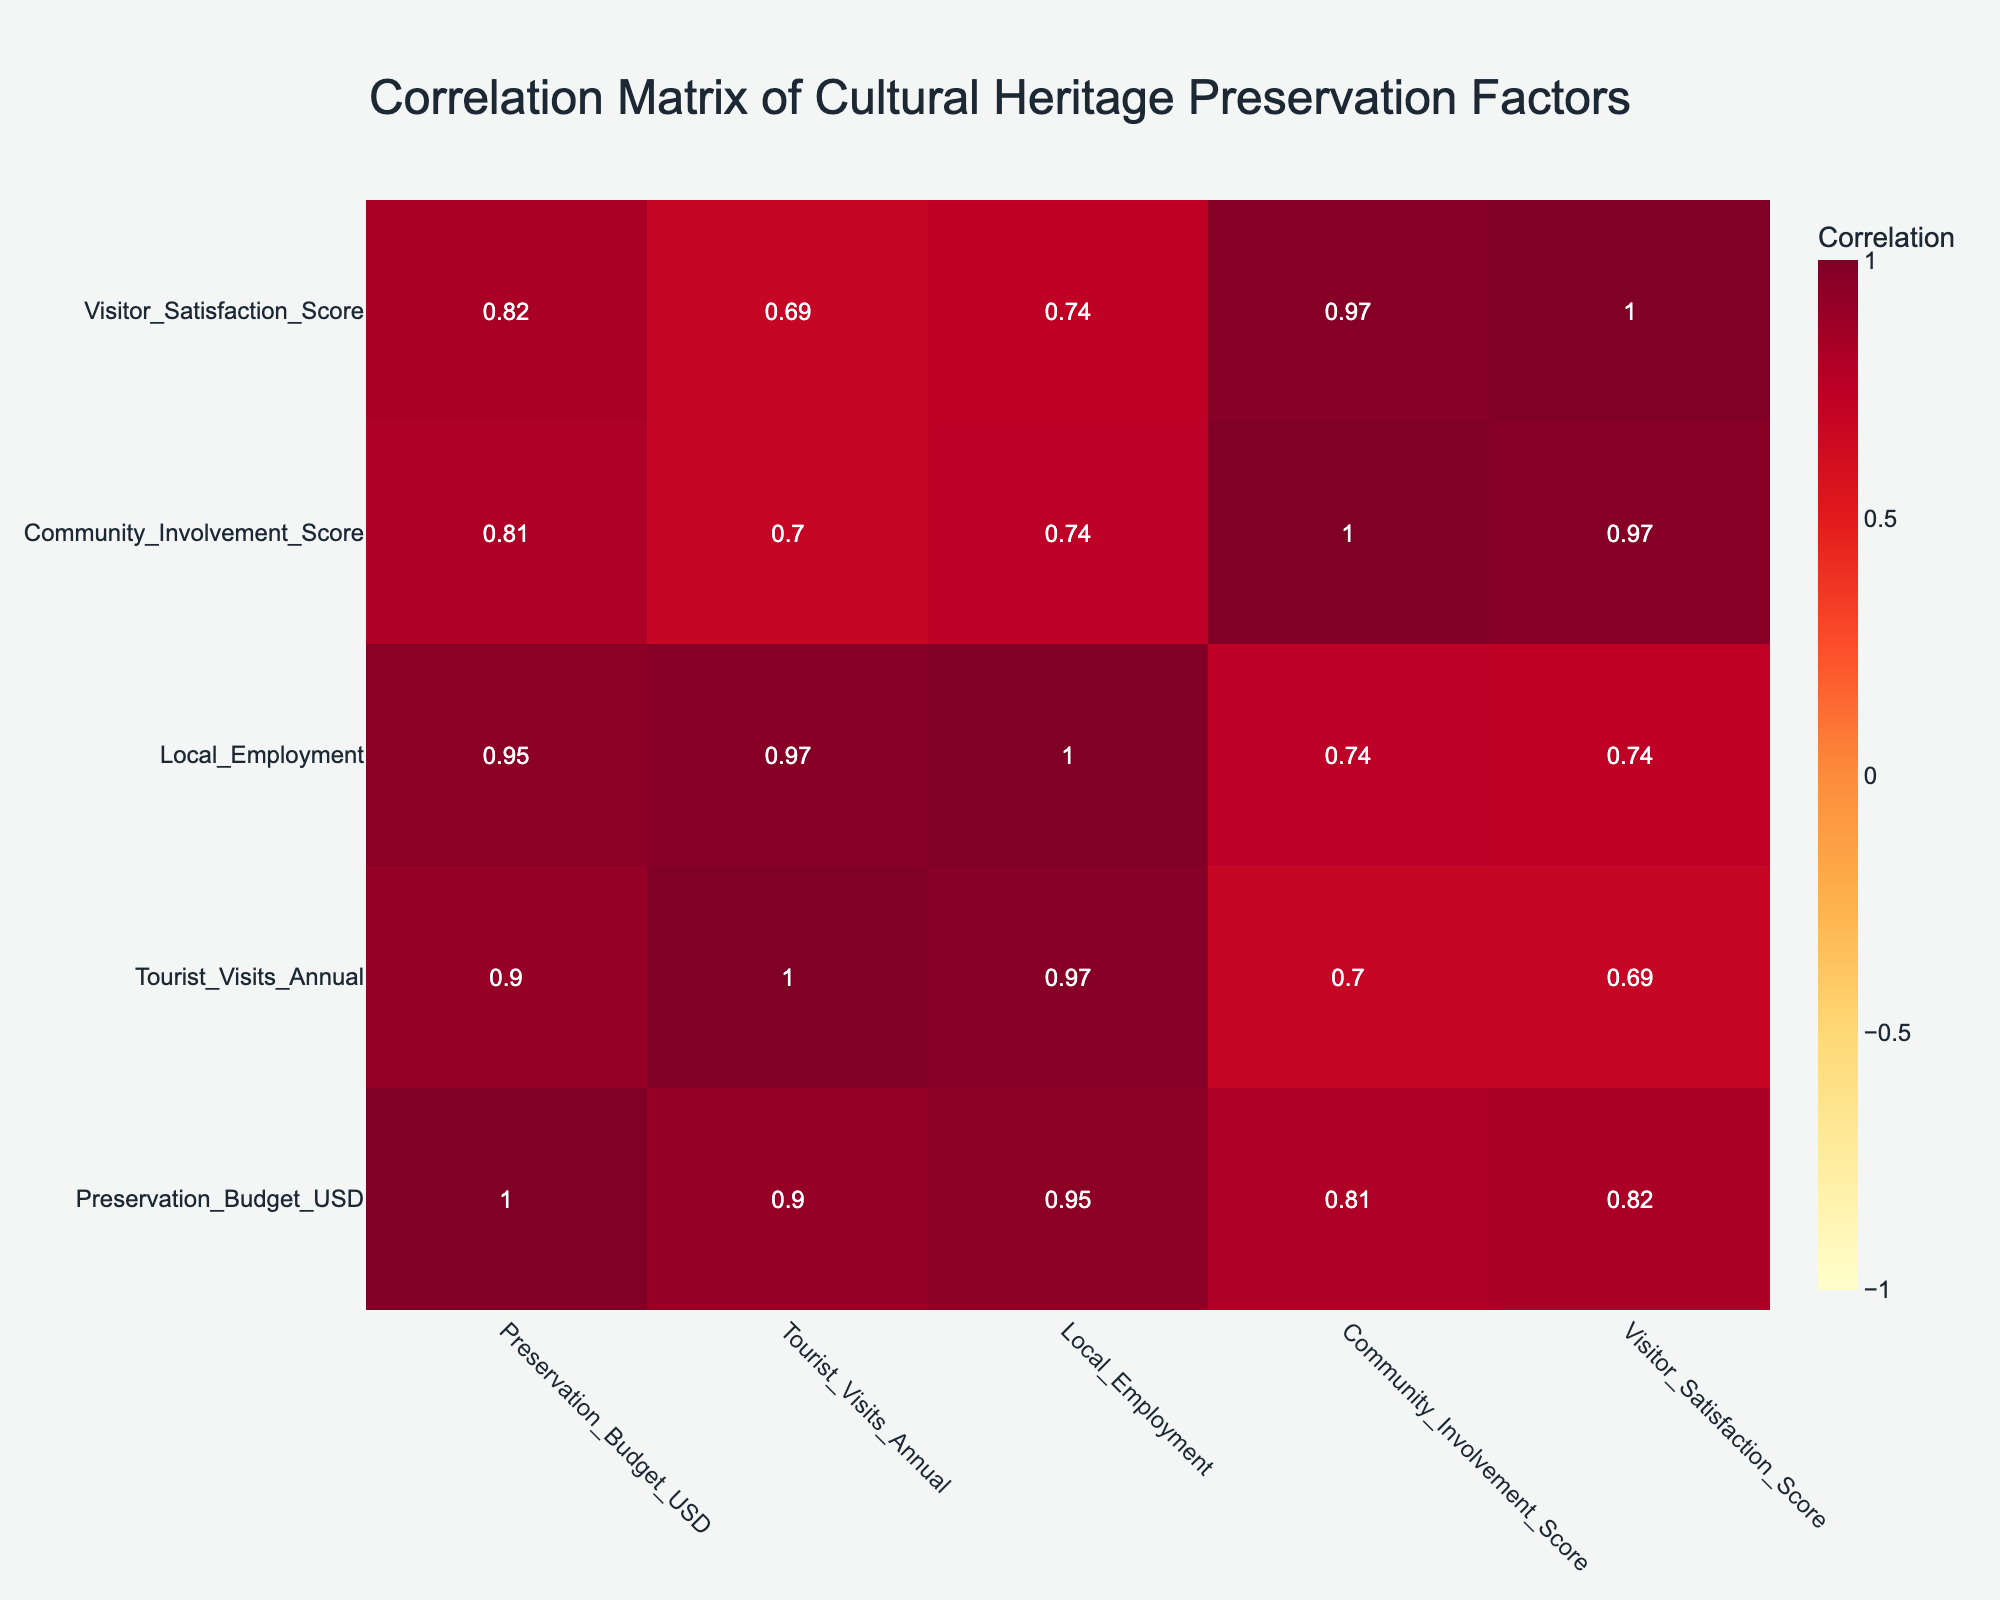What is the preservation budget for Göbekli Tepe? The preservation budget for Göbekli Tepe is listed directly in the table under "Preservation_Budget_USD," which is 1,000,000 USD.
Answer: 1,000,000 USD How many tourist visits does Mardin Old Town receive annually? The annual tourist visits to Mardin Old Town can be found in the column under "Tourist_Visits_Annual," which shows a value of 50,000 visits.
Answer: 50,000 visits Is there a correlation between Preservation Budget and Tourist Visits? A correlation matrix reveals the correlation coefficient between the "Preservation_Budget_USD" and "Tourist_Visits_Annual." The coefficient is 0.95, indicating a strong positive correlation.
Answer: Yes What is the total number of local employment opportunities across all sites? To find the total number of local employment opportunities, sum the values in the "Local_Employment" column: 50 + 200 + 300 + 80 + 75 + 30 + 40 = 775.
Answer: 775 Does Hasankeyf have a higher Visitor Satisfaction Score than Kızıltepe Historical Site? Comparing the "Visitor_Satisfaction_Score" between Hasankeyf (4.1) and Kızıltepe Historical Site (4.5), it is clear that Kızıltepe has a higher score.
Answer: Yes What is the average number of tourist visits among all sites? First, sum the tourist visits: 15,000 + 50,000 + 100,000 + 25,000 + 30,000 + 18,000 + 22,000 = 250,000. Then divide by the number of sites (7): 250,000 / 7 = 35,714.29.
Answer: 35,714.29 Which site has the highest community involvement score? By examining the "Community_Involvement_Score" column, we find that Göbekli Tepe has the highest score at 90.
Answer: Göbekli Tepe Is Nusaybin Archaeological Site's Visitor Satisfaction Score less than 4.5? Looking at the "Visitor_Satisfaction_Score" for Nusaybin, which is 4.3, we can confirm that it is indeed less than 4.5.
Answer: Yes 